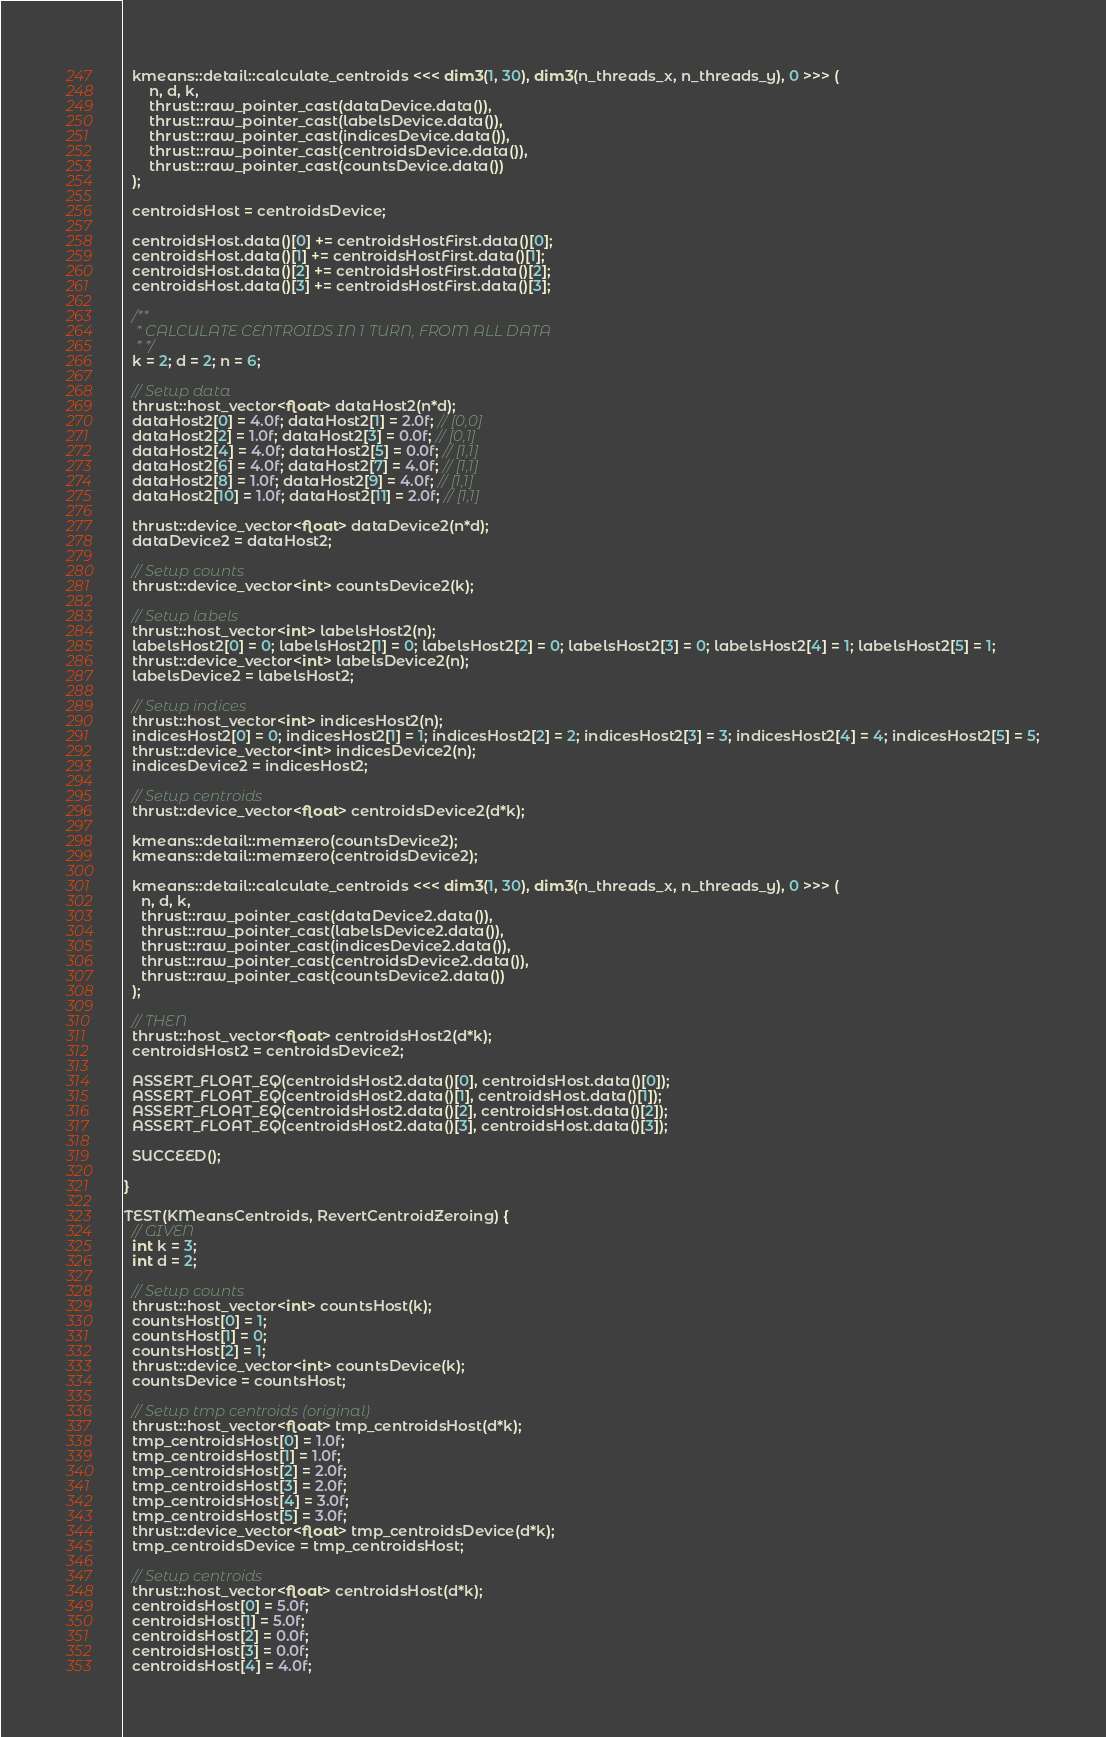<code> <loc_0><loc_0><loc_500><loc_500><_Cuda_>  kmeans::detail::calculate_centroids <<< dim3(1, 30), dim3(n_threads_x, n_threads_y), 0 >>> (
      n, d, k,
      thrust::raw_pointer_cast(dataDevice.data()),
      thrust::raw_pointer_cast(labelsDevice.data()),
      thrust::raw_pointer_cast(indicesDevice.data()),
      thrust::raw_pointer_cast(centroidsDevice.data()),
      thrust::raw_pointer_cast(countsDevice.data())
  );

  centroidsHost = centroidsDevice;

  centroidsHost.data()[0] += centroidsHostFirst.data()[0];
  centroidsHost.data()[1] += centroidsHostFirst.data()[1];
  centroidsHost.data()[2] += centroidsHostFirst.data()[2];
  centroidsHost.data()[3] += centroidsHostFirst.data()[3];

  /**
   * CALCULATE CENTROIDS IN 1 TURN, FROM ALL DATA
   * */
  k = 2; d = 2; n = 6;

  // Setup data
  thrust::host_vector<float> dataHost2(n*d);
  dataHost2[0] = 4.0f; dataHost2[1] = 2.0f; // [0,0]
  dataHost2[2] = 1.0f; dataHost2[3] = 0.0f; // [0,1]
  dataHost2[4] = 4.0f; dataHost2[5] = 0.0f; // [1,1]
  dataHost2[6] = 4.0f; dataHost2[7] = 4.0f; // [1,1]
  dataHost2[8] = 1.0f; dataHost2[9] = 4.0f; // [1,1]
  dataHost2[10] = 1.0f; dataHost2[11] = 2.0f; // [1,1]

  thrust::device_vector<float> dataDevice2(n*d);
  dataDevice2 = dataHost2;

  // Setup counts
  thrust::device_vector<int> countsDevice2(k);

  // Setup labels
  thrust::host_vector<int> labelsHost2(n);
  labelsHost2[0] = 0; labelsHost2[1] = 0; labelsHost2[2] = 0; labelsHost2[3] = 0; labelsHost2[4] = 1; labelsHost2[5] = 1;
  thrust::device_vector<int> labelsDevice2(n);
  labelsDevice2 = labelsHost2;

  // Setup indices
  thrust::host_vector<int> indicesHost2(n);
  indicesHost2[0] = 0; indicesHost2[1] = 1; indicesHost2[2] = 2; indicesHost2[3] = 3; indicesHost2[4] = 4; indicesHost2[5] = 5;
  thrust::device_vector<int> indicesDevice2(n);
  indicesDevice2 = indicesHost2;

  // Setup centroids
  thrust::device_vector<float> centroidsDevice2(d*k);

  kmeans::detail::memzero(countsDevice2);
  kmeans::detail::memzero(centroidsDevice2);

  kmeans::detail::calculate_centroids <<< dim3(1, 30), dim3(n_threads_x, n_threads_y), 0 >>> (
    n, d, k,
    thrust::raw_pointer_cast(dataDevice2.data()),
    thrust::raw_pointer_cast(labelsDevice2.data()),
    thrust::raw_pointer_cast(indicesDevice2.data()),
    thrust::raw_pointer_cast(centroidsDevice2.data()),
    thrust::raw_pointer_cast(countsDevice2.data())
  );

  // THEN
  thrust::host_vector<float> centroidsHost2(d*k);
  centroidsHost2 = centroidsDevice2;

  ASSERT_FLOAT_EQ(centroidsHost2.data()[0], centroidsHost.data()[0]);
  ASSERT_FLOAT_EQ(centroidsHost2.data()[1], centroidsHost.data()[1]);
  ASSERT_FLOAT_EQ(centroidsHost2.data()[2], centroidsHost.data()[2]);
  ASSERT_FLOAT_EQ(centroidsHost2.data()[3], centroidsHost.data()[3]);

  SUCCEED();

}

TEST(KMeansCentroids, RevertCentroidZeroing) {
  // GIVEN
  int k = 3;
  int d = 2;

  // Setup counts
  thrust::host_vector<int> countsHost(k);
  countsHost[0] = 1;
  countsHost[1] = 0;
  countsHost[2] = 1;
  thrust::device_vector<int> countsDevice(k);
  countsDevice = countsHost;

  // Setup tmp centroids (original)
  thrust::host_vector<float> tmp_centroidsHost(d*k);
  tmp_centroidsHost[0] = 1.0f;
  tmp_centroidsHost[1] = 1.0f;
  tmp_centroidsHost[2] = 2.0f;
  tmp_centroidsHost[3] = 2.0f;
  tmp_centroidsHost[4] = 3.0f;
  tmp_centroidsHost[5] = 3.0f;
  thrust::device_vector<float> tmp_centroidsDevice(d*k);
  tmp_centroidsDevice = tmp_centroidsHost;

  // Setup centroids
  thrust::host_vector<float> centroidsHost(d*k);
  centroidsHost[0] = 5.0f;
  centroidsHost[1] = 5.0f;
  centroidsHost[2] = 0.0f;
  centroidsHost[3] = 0.0f;
  centroidsHost[4] = 4.0f;</code> 